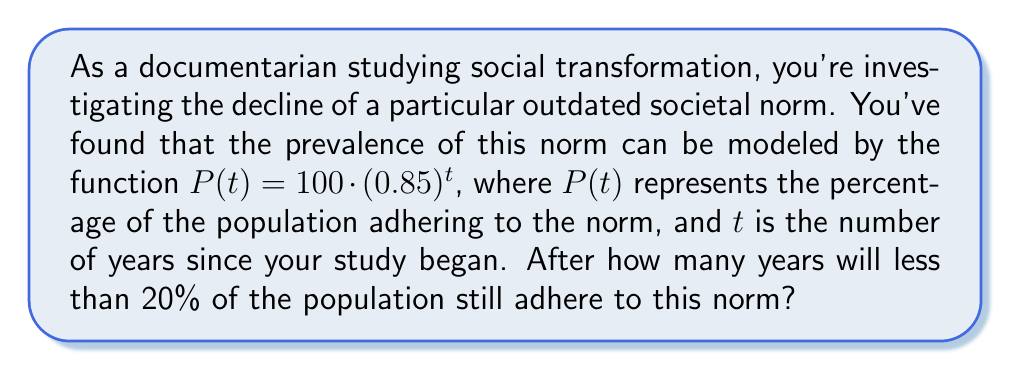Teach me how to tackle this problem. To solve this problem, we need to find the value of $t$ where $P(t)$ becomes less than 20. Let's approach this step-by-step:

1) We start with the equation: $P(t) = 100 \cdot (0.85)^t$

2) We want to find when $P(t) < 20$, so we set up the inequality:
   $100 \cdot (0.85)^t < 20$

3) Divide both sides by 100:
   $(0.85)^t < 0.2$

4) Take the natural log of both sides:
   $\ln(0.85)^t < \ln(0.2)$

5) Using the logarithm property $\ln(a^b) = b\ln(a)$:
   $t \cdot \ln(0.85) < \ln(0.2)$

6) Divide both sides by $\ln(0.85)$ (note that $\ln(0.85)$ is negative, so the inequality sign flips):
   $t > \frac{\ln(0.2)}{\ln(0.85)}$

7) Calculate the right side:
   $t > \frac{\ln(0.2)}{\ln(0.85)} \approx 10.4752$

8) Since $t$ represents years and must be a whole number, we round up to the next integer.

Therefore, after 11 years, less than 20% of the population will adhere to this outdated norm.
Answer: 11 years 